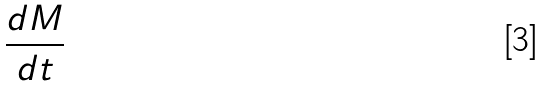Convert formula to latex. <formula><loc_0><loc_0><loc_500><loc_500>\frac { d M } { d t }</formula> 